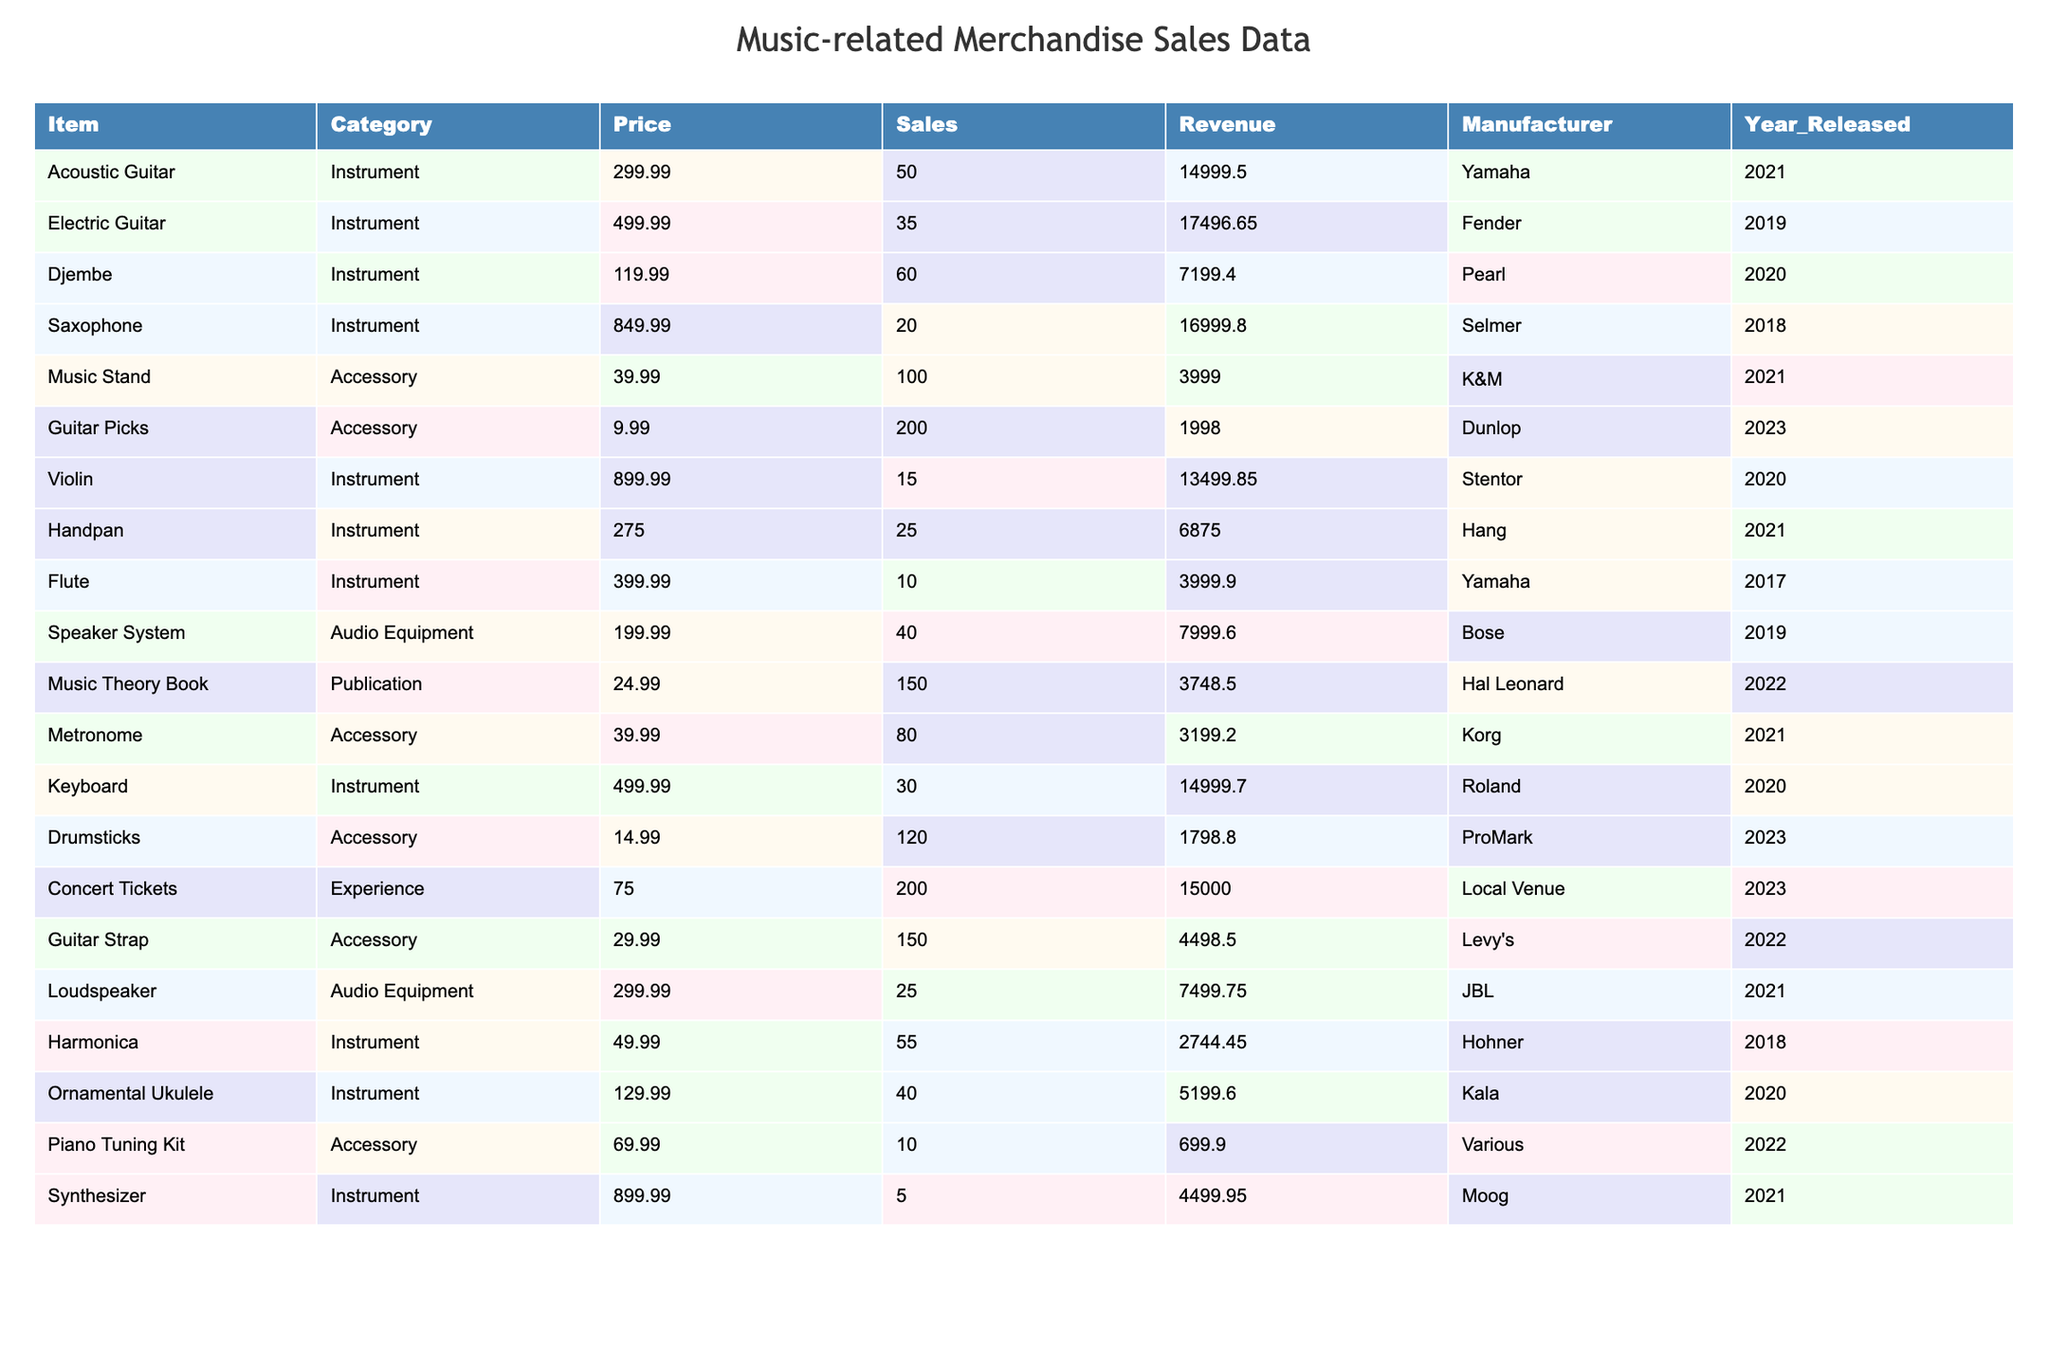What is the total revenue generated from the sale of Concert Tickets? The revenue for Concert Tickets is listed as 15000.00, which indicates the total revenue generated from that category.
Answer: 15000.00 Which item sold the most units? The item with the highest sales figure is the Music Stand, with 100 units sold, which is more than any other item in the table.
Answer: Music Stand What is the average price of all accessories? The prices of accessories are: 39.99 (Music Stand), 9.99 (Guitar Picks), 39.99 (Metronome), 14.99 (Drumsticks), and 29.99 (Guitar Strap). The total price is 134.95 and there are 5 accessories, so the average price is 134.95/5 = 26.99.
Answer: 26.99 Did the Djembe generate more revenue than the Flute? The revenue from the Djembe is 7199.40, while the revenue from the Flute is 3999.90. Since 7199.40 is greater than 3999.90, the answer is yes.
Answer: Yes What is the total number of instruments sold? The sales figures for instruments (Acoustic Guitar, Electric Guitar, Djembe, Saxophone, Violin, Handpan, Flute, Keyboard, Harmonica, Ornamental Ukulele, Synthesizer) add up to 50 + 35 + 60 + 20 + 15 + 25 + 10 + 30 + 55 + 40 + 5 = 350.
Answer: 350 Which manufacturer has the highest total sales? We need to calculate the total sales for each manufacturer. Yamaha (50+10=60), Fender (35), Pearl (60), Selmer (20), Stentor (15), Hang (25), Korg (80), Roland (30), Hohner (55), Kala (40), Moog (5). The highest is Korg with 80 units sold.
Answer: Korg How much more revenue did the Electric Guitar generate than the Djembe? The revenue from the Electric Guitar is 17496.65 and from the Djembe is 7199.40. Subtracting these gives 17496.65 - 7199.40 = 10797.25, indicating that the Electric Guitar generated 10797.25 more in revenue.
Answer: 10797.25 What percentage of total merchandise revenue does the Acoustic Guitar represent? The total revenue from all items is calculated by adding all the Revenue column values. The revenue for the Acoustic Guitar is 14999.50. If total revenue is 14999.50 / (Sum of all Revenue) * 100, this percentage can be derived. (Total Revenue is 14999.50 + 17496.65 + ... + 4499.95.)
Answer: Approximately 13.18% Which item has the lowest sales figure? The item with the lowest sales figure in the table is the Synthesizer, with only 5 units sold, which is the smallest number across all items.
Answer: Synthesizer Did any item generate revenue of less than 2000? We can check each item's revenue; Guitar Picks made 1998.00, which is less than 2000. Therefore, the answer is yes.
Answer: Yes 